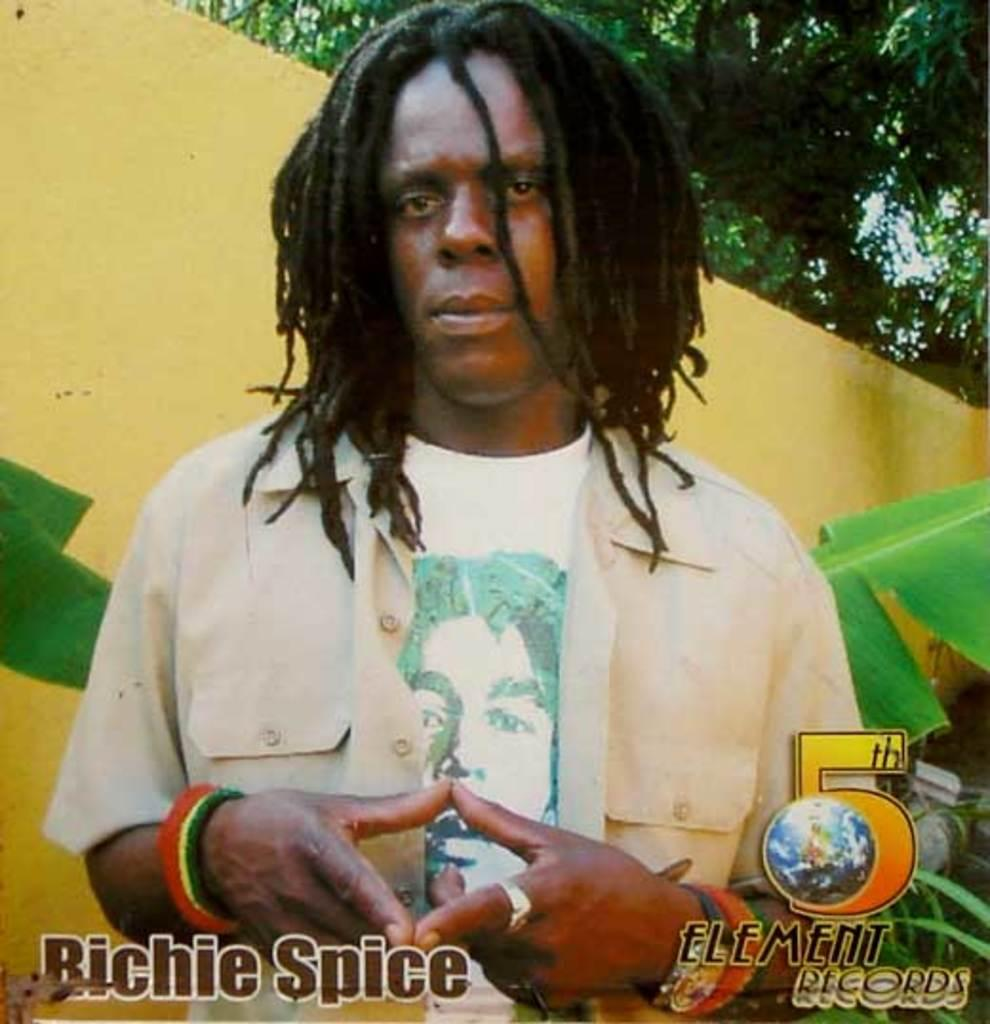What is the main subject of the image? There is a man standing in the image. What can be seen in the background of the image? There is a wall and trees in the background of the image. Are there any text elements in the image? Yes, there is text in the bottom right and bottom left of the image. Is there any smoke coming from the man's clothing in the image? No, there is no smoke present in the image. What type of dolls are sitting on the wall in the image? There are no dolls present in the image; it features a man standing in front of a wall with trees in the background. 